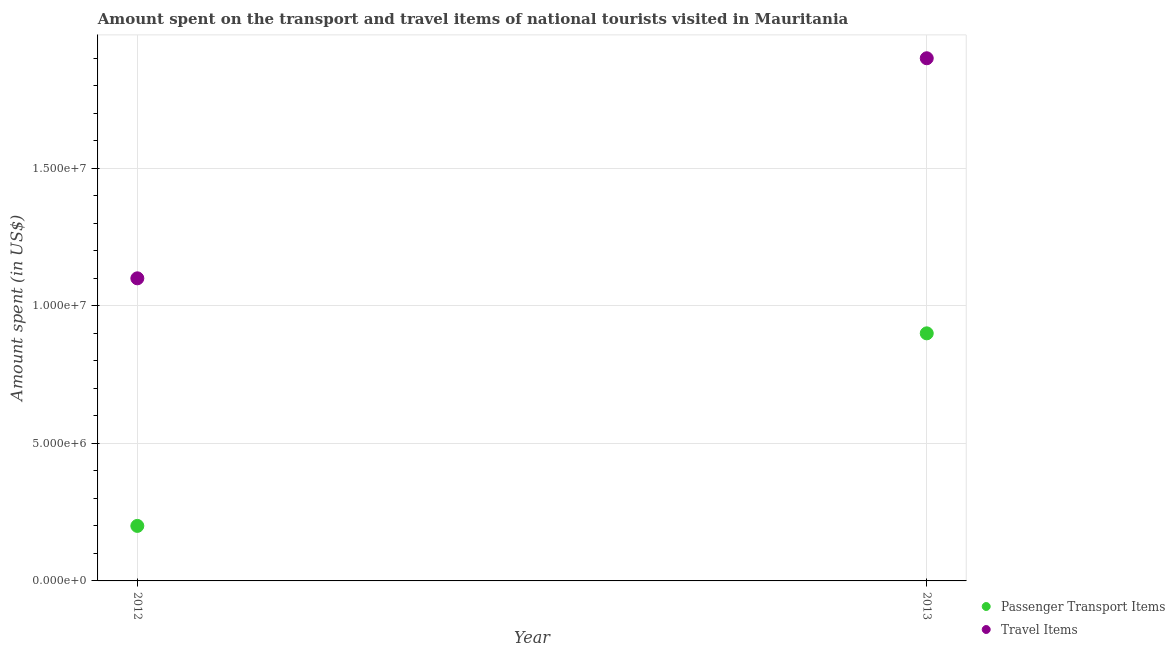Is the number of dotlines equal to the number of legend labels?
Your response must be concise. Yes. What is the amount spent on passenger transport items in 2012?
Give a very brief answer. 2.00e+06. Across all years, what is the maximum amount spent on passenger transport items?
Your response must be concise. 9.00e+06. Across all years, what is the minimum amount spent on passenger transport items?
Your answer should be very brief. 2.00e+06. In which year was the amount spent in travel items maximum?
Provide a short and direct response. 2013. In which year was the amount spent in travel items minimum?
Provide a succinct answer. 2012. What is the total amount spent in travel items in the graph?
Make the answer very short. 3.00e+07. What is the difference between the amount spent in travel items in 2012 and that in 2013?
Your answer should be compact. -8.00e+06. What is the difference between the amount spent on passenger transport items in 2013 and the amount spent in travel items in 2012?
Keep it short and to the point. -2.00e+06. What is the average amount spent on passenger transport items per year?
Your answer should be compact. 5.50e+06. In the year 2013, what is the difference between the amount spent in travel items and amount spent on passenger transport items?
Provide a succinct answer. 1.00e+07. What is the ratio of the amount spent on passenger transport items in 2012 to that in 2013?
Offer a terse response. 0.22. In how many years, is the amount spent on passenger transport items greater than the average amount spent on passenger transport items taken over all years?
Your answer should be compact. 1. Does the amount spent in travel items monotonically increase over the years?
Ensure brevity in your answer.  Yes. Is the amount spent on passenger transport items strictly greater than the amount spent in travel items over the years?
Make the answer very short. No. Is the amount spent in travel items strictly less than the amount spent on passenger transport items over the years?
Provide a short and direct response. No. How many dotlines are there?
Give a very brief answer. 2. What is the difference between two consecutive major ticks on the Y-axis?
Your answer should be compact. 5.00e+06. Are the values on the major ticks of Y-axis written in scientific E-notation?
Offer a terse response. Yes. Does the graph contain grids?
Ensure brevity in your answer.  Yes. Where does the legend appear in the graph?
Make the answer very short. Bottom right. What is the title of the graph?
Keep it short and to the point. Amount spent on the transport and travel items of national tourists visited in Mauritania. What is the label or title of the Y-axis?
Your answer should be compact. Amount spent (in US$). What is the Amount spent (in US$) of Passenger Transport Items in 2012?
Your answer should be very brief. 2.00e+06. What is the Amount spent (in US$) in Travel Items in 2012?
Give a very brief answer. 1.10e+07. What is the Amount spent (in US$) in Passenger Transport Items in 2013?
Provide a short and direct response. 9.00e+06. What is the Amount spent (in US$) of Travel Items in 2013?
Your answer should be compact. 1.90e+07. Across all years, what is the maximum Amount spent (in US$) in Passenger Transport Items?
Your response must be concise. 9.00e+06. Across all years, what is the maximum Amount spent (in US$) in Travel Items?
Provide a succinct answer. 1.90e+07. Across all years, what is the minimum Amount spent (in US$) in Passenger Transport Items?
Provide a short and direct response. 2.00e+06. Across all years, what is the minimum Amount spent (in US$) of Travel Items?
Ensure brevity in your answer.  1.10e+07. What is the total Amount spent (in US$) in Passenger Transport Items in the graph?
Provide a short and direct response. 1.10e+07. What is the total Amount spent (in US$) of Travel Items in the graph?
Keep it short and to the point. 3.00e+07. What is the difference between the Amount spent (in US$) of Passenger Transport Items in 2012 and that in 2013?
Your response must be concise. -7.00e+06. What is the difference between the Amount spent (in US$) of Travel Items in 2012 and that in 2013?
Offer a terse response. -8.00e+06. What is the difference between the Amount spent (in US$) in Passenger Transport Items in 2012 and the Amount spent (in US$) in Travel Items in 2013?
Provide a succinct answer. -1.70e+07. What is the average Amount spent (in US$) in Passenger Transport Items per year?
Provide a succinct answer. 5.50e+06. What is the average Amount spent (in US$) in Travel Items per year?
Provide a short and direct response. 1.50e+07. In the year 2012, what is the difference between the Amount spent (in US$) in Passenger Transport Items and Amount spent (in US$) in Travel Items?
Give a very brief answer. -9.00e+06. In the year 2013, what is the difference between the Amount spent (in US$) in Passenger Transport Items and Amount spent (in US$) in Travel Items?
Give a very brief answer. -1.00e+07. What is the ratio of the Amount spent (in US$) in Passenger Transport Items in 2012 to that in 2013?
Offer a very short reply. 0.22. What is the ratio of the Amount spent (in US$) in Travel Items in 2012 to that in 2013?
Offer a very short reply. 0.58. What is the difference between the highest and the second highest Amount spent (in US$) in Passenger Transport Items?
Give a very brief answer. 7.00e+06. What is the difference between the highest and the second highest Amount spent (in US$) of Travel Items?
Your answer should be compact. 8.00e+06. What is the difference between the highest and the lowest Amount spent (in US$) in Passenger Transport Items?
Your response must be concise. 7.00e+06. What is the difference between the highest and the lowest Amount spent (in US$) of Travel Items?
Your answer should be compact. 8.00e+06. 